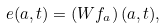Convert formula to latex. <formula><loc_0><loc_0><loc_500><loc_500>e ( a , t ) = \left ( W f _ { a } \right ) ( a , t ) ,</formula> 